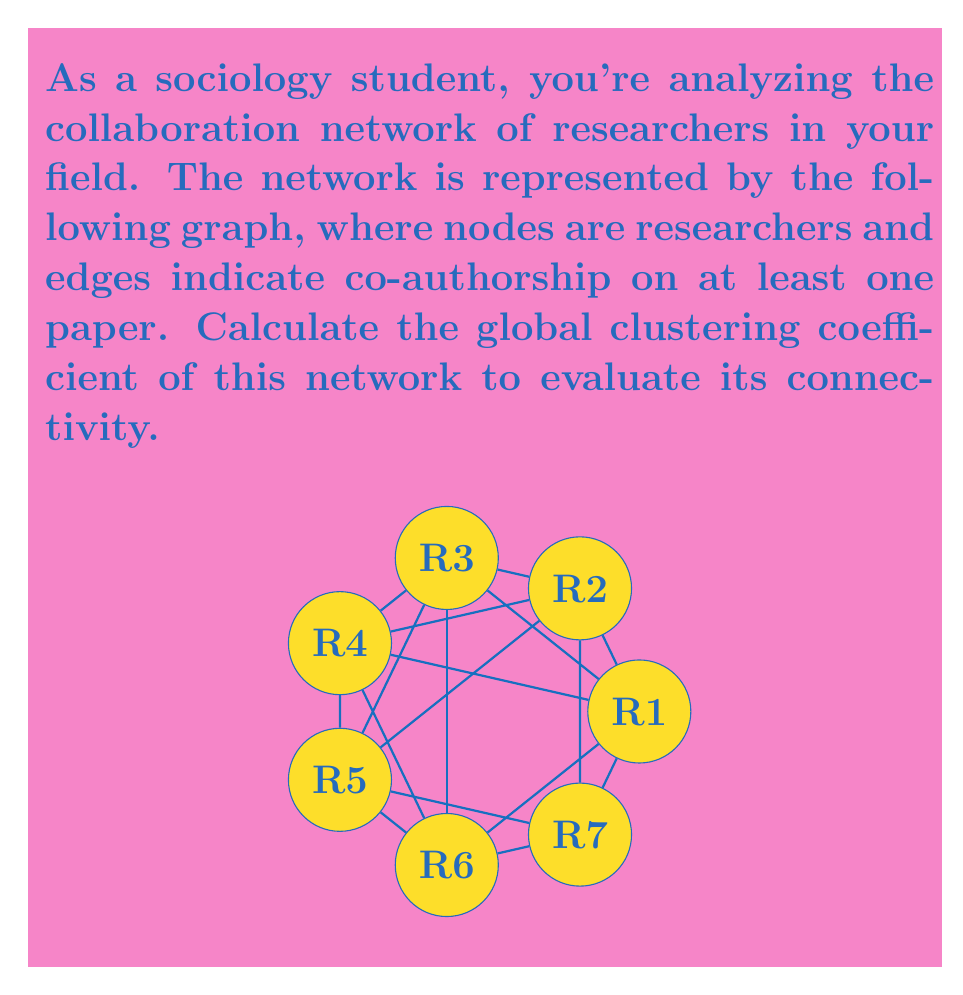Can you solve this math problem? To calculate the global clustering coefficient of this network, we need to follow these steps:

1) The global clustering coefficient $C$ is defined as:

   $$C = \frac{3 \times \text{number of triangles}}{\text{number of connected triples}}$$

2) First, let's count the number of triangles in the graph:
   - (R1, R2, R3), (R1, R3, R4), (R1, R4, R5), (R1, R5, R6), (R1, R6, R7), (R1, R7, R2)
   - (R2, R3, R4), (R2, R4, R5), (R2, R5, R6), (R2, R6, R7)
   - (R3, R4, R5), (R3, R5, R6), (R3, R6, R7)
   - (R4, R5, R6), (R4, R6, R7)
   - (R5, R6, R7)

   Total number of triangles = 16

3) Now, let's count the number of connected triples. A connected triple is a node with edges running to an unordered pair of other nodes. Each triangle contributes 3 connected triples.

   For each node:
   R1: $\binom{6}{2} = 15$
   R2, R3, R4, R5, R6, R7: each has $\binom{4}{2} = 6$

   Total number of connected triples = $15 + 6 \times 6 = 51$

4) Now we can calculate the global clustering coefficient:

   $$C = \frac{3 \times 16}{51} = \frac{48}{51} = \frac{16}{17} \approx 0.9412$$
Answer: $\frac{16}{17}$ 